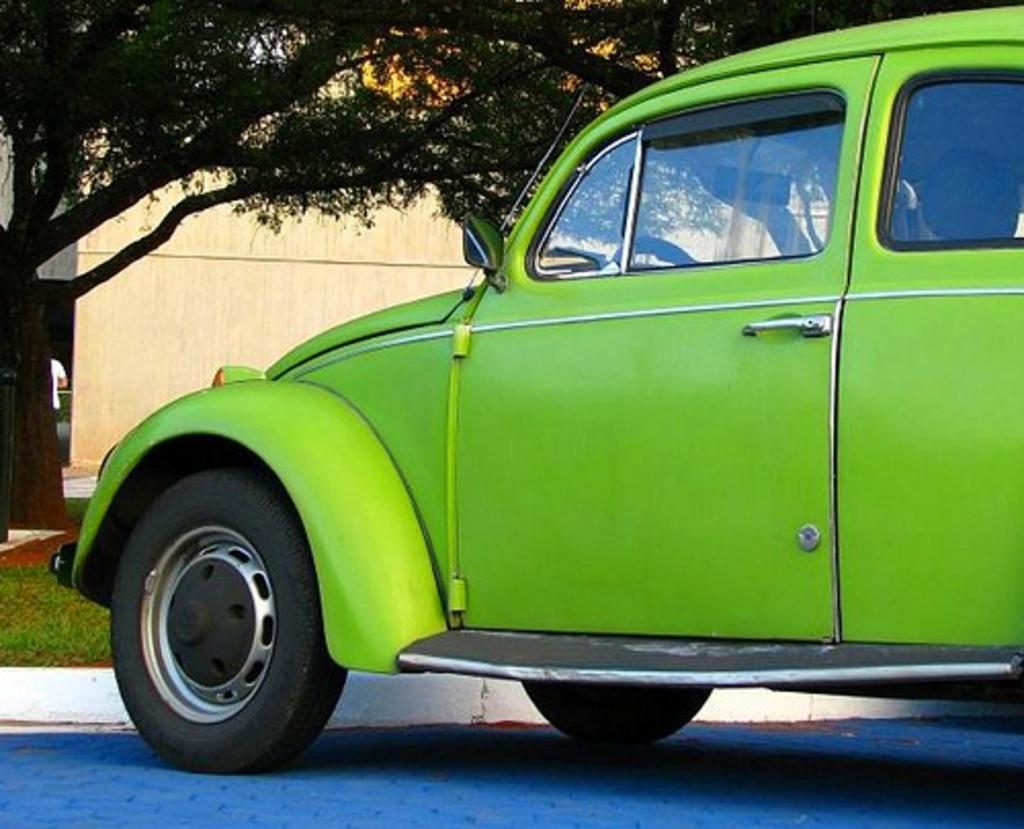What is the main subject in the center of the image? There is a car in the center of the image. What can be seen in the background of the image? There are houses, trees, and a person in the background of the image. What is at the bottom of the image? There is a walkway and grass at the bottom of the image. Can you see the fireman's aunt in the nest in the image? There is no fireman, aunt, or nest present in the image. 